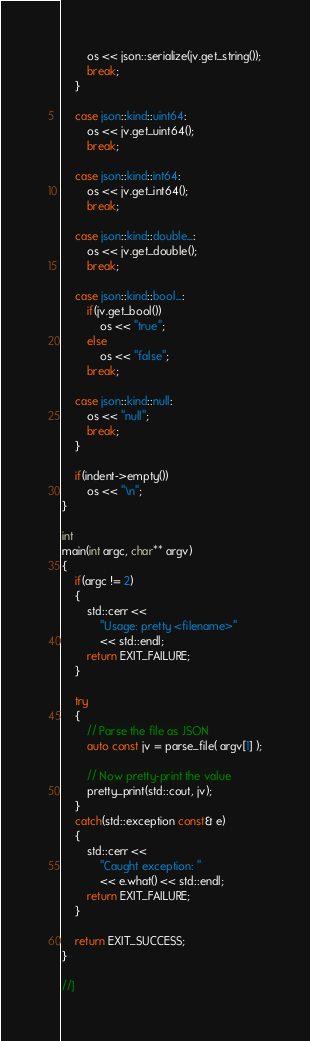<code> <loc_0><loc_0><loc_500><loc_500><_C++_>        os << json::serialize(jv.get_string());
        break;
    }

    case json::kind::uint64:
        os << jv.get_uint64();
        break;

    case json::kind::int64:
        os << jv.get_int64();
        break;

    case json::kind::double_:
        os << jv.get_double();
        break;

    case json::kind::bool_:
        if(jv.get_bool())
            os << "true";
        else
            os << "false";
        break;

    case json::kind::null:
        os << "null";
        break;
    }

    if(indent->empty())
        os << "\n";
}

int
main(int argc, char** argv)
{
    if(argc != 2)
    {
        std::cerr <<
            "Usage: pretty <filename>"
            << std::endl;
        return EXIT_FAILURE;
    }

    try
    {
        // Parse the file as JSON
        auto const jv = parse_file( argv[1] );

        // Now pretty-print the value
        pretty_print(std::cout, jv);
    }
    catch(std::exception const& e)
    {
        std::cerr <<
            "Caught exception: "
            << e.what() << std::endl;
        return EXIT_FAILURE;
    }

    return EXIT_SUCCESS;
}

//]
</code> 